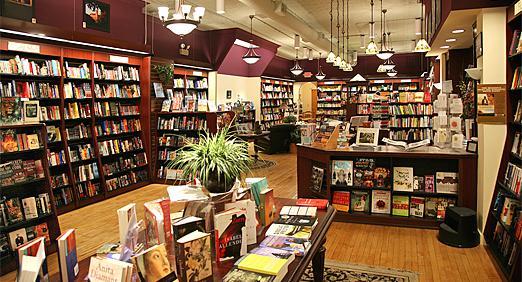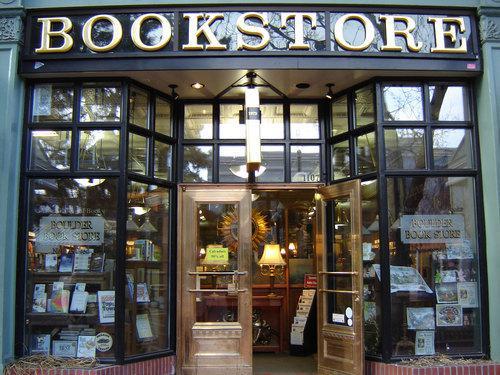The first image is the image on the left, the second image is the image on the right. Assess this claim about the two images: "There is at least one person looking at books on a shelf.". Correct or not? Answer yes or no. No. The first image is the image on the left, the second image is the image on the right. For the images displayed, is the sentence "The right image has visible windows, the left does not." factually correct? Answer yes or no. Yes. 